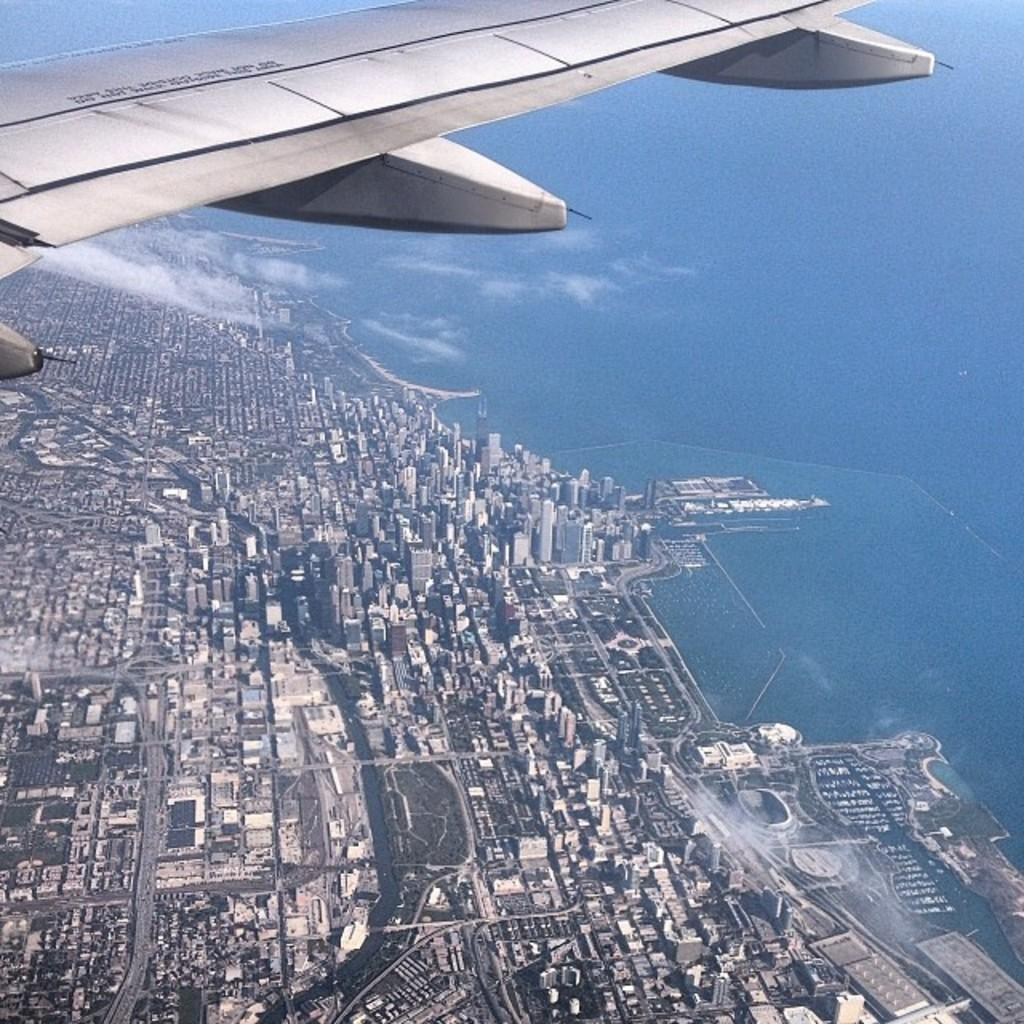What is the main subject in the sky in the image? There is an airplane in the sky in the image. What can be seen at the bottom of the image? There are buildings at the bottom of the image. Can you see a snail crawling on the buildings in the image? No, there is no snail visible on the buildings in the image. 